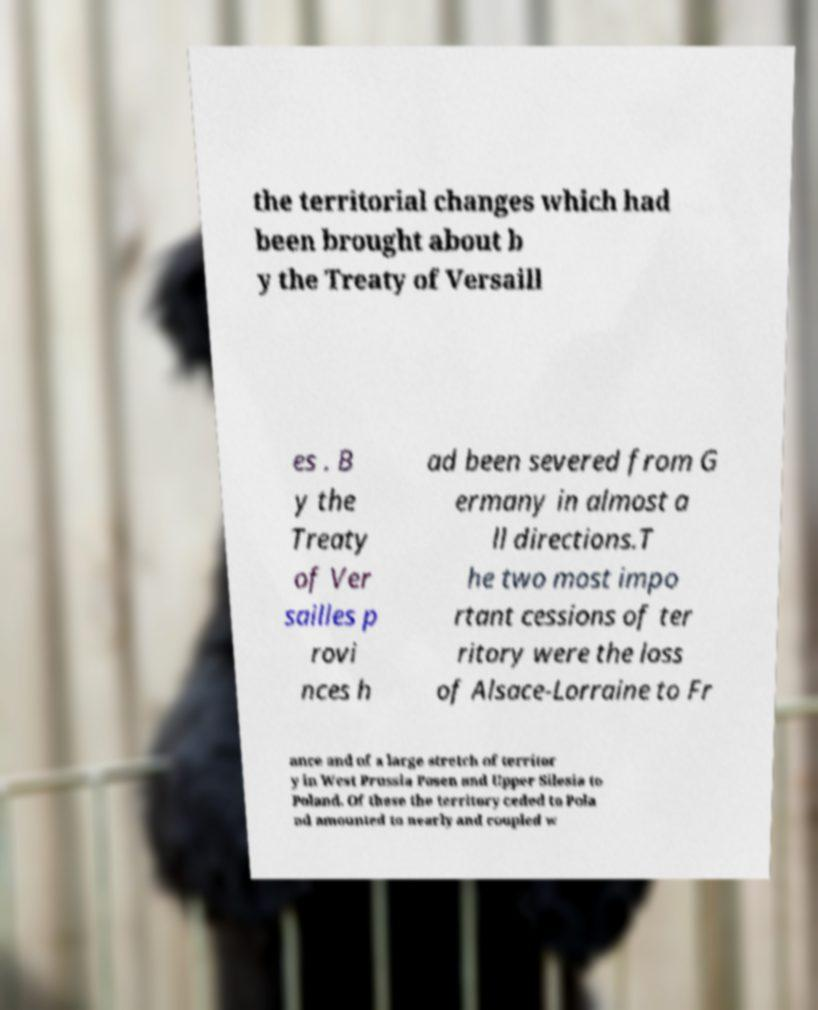There's text embedded in this image that I need extracted. Can you transcribe it verbatim? the territorial changes which had been brought about b y the Treaty of Versaill es . B y the Treaty of Ver sailles p rovi nces h ad been severed from G ermany in almost a ll directions.T he two most impo rtant cessions of ter ritory were the loss of Alsace-Lorraine to Fr ance and of a large stretch of territor y in West Prussia Posen and Upper Silesia to Poland. Of these the territory ceded to Pola nd amounted to nearly and coupled w 